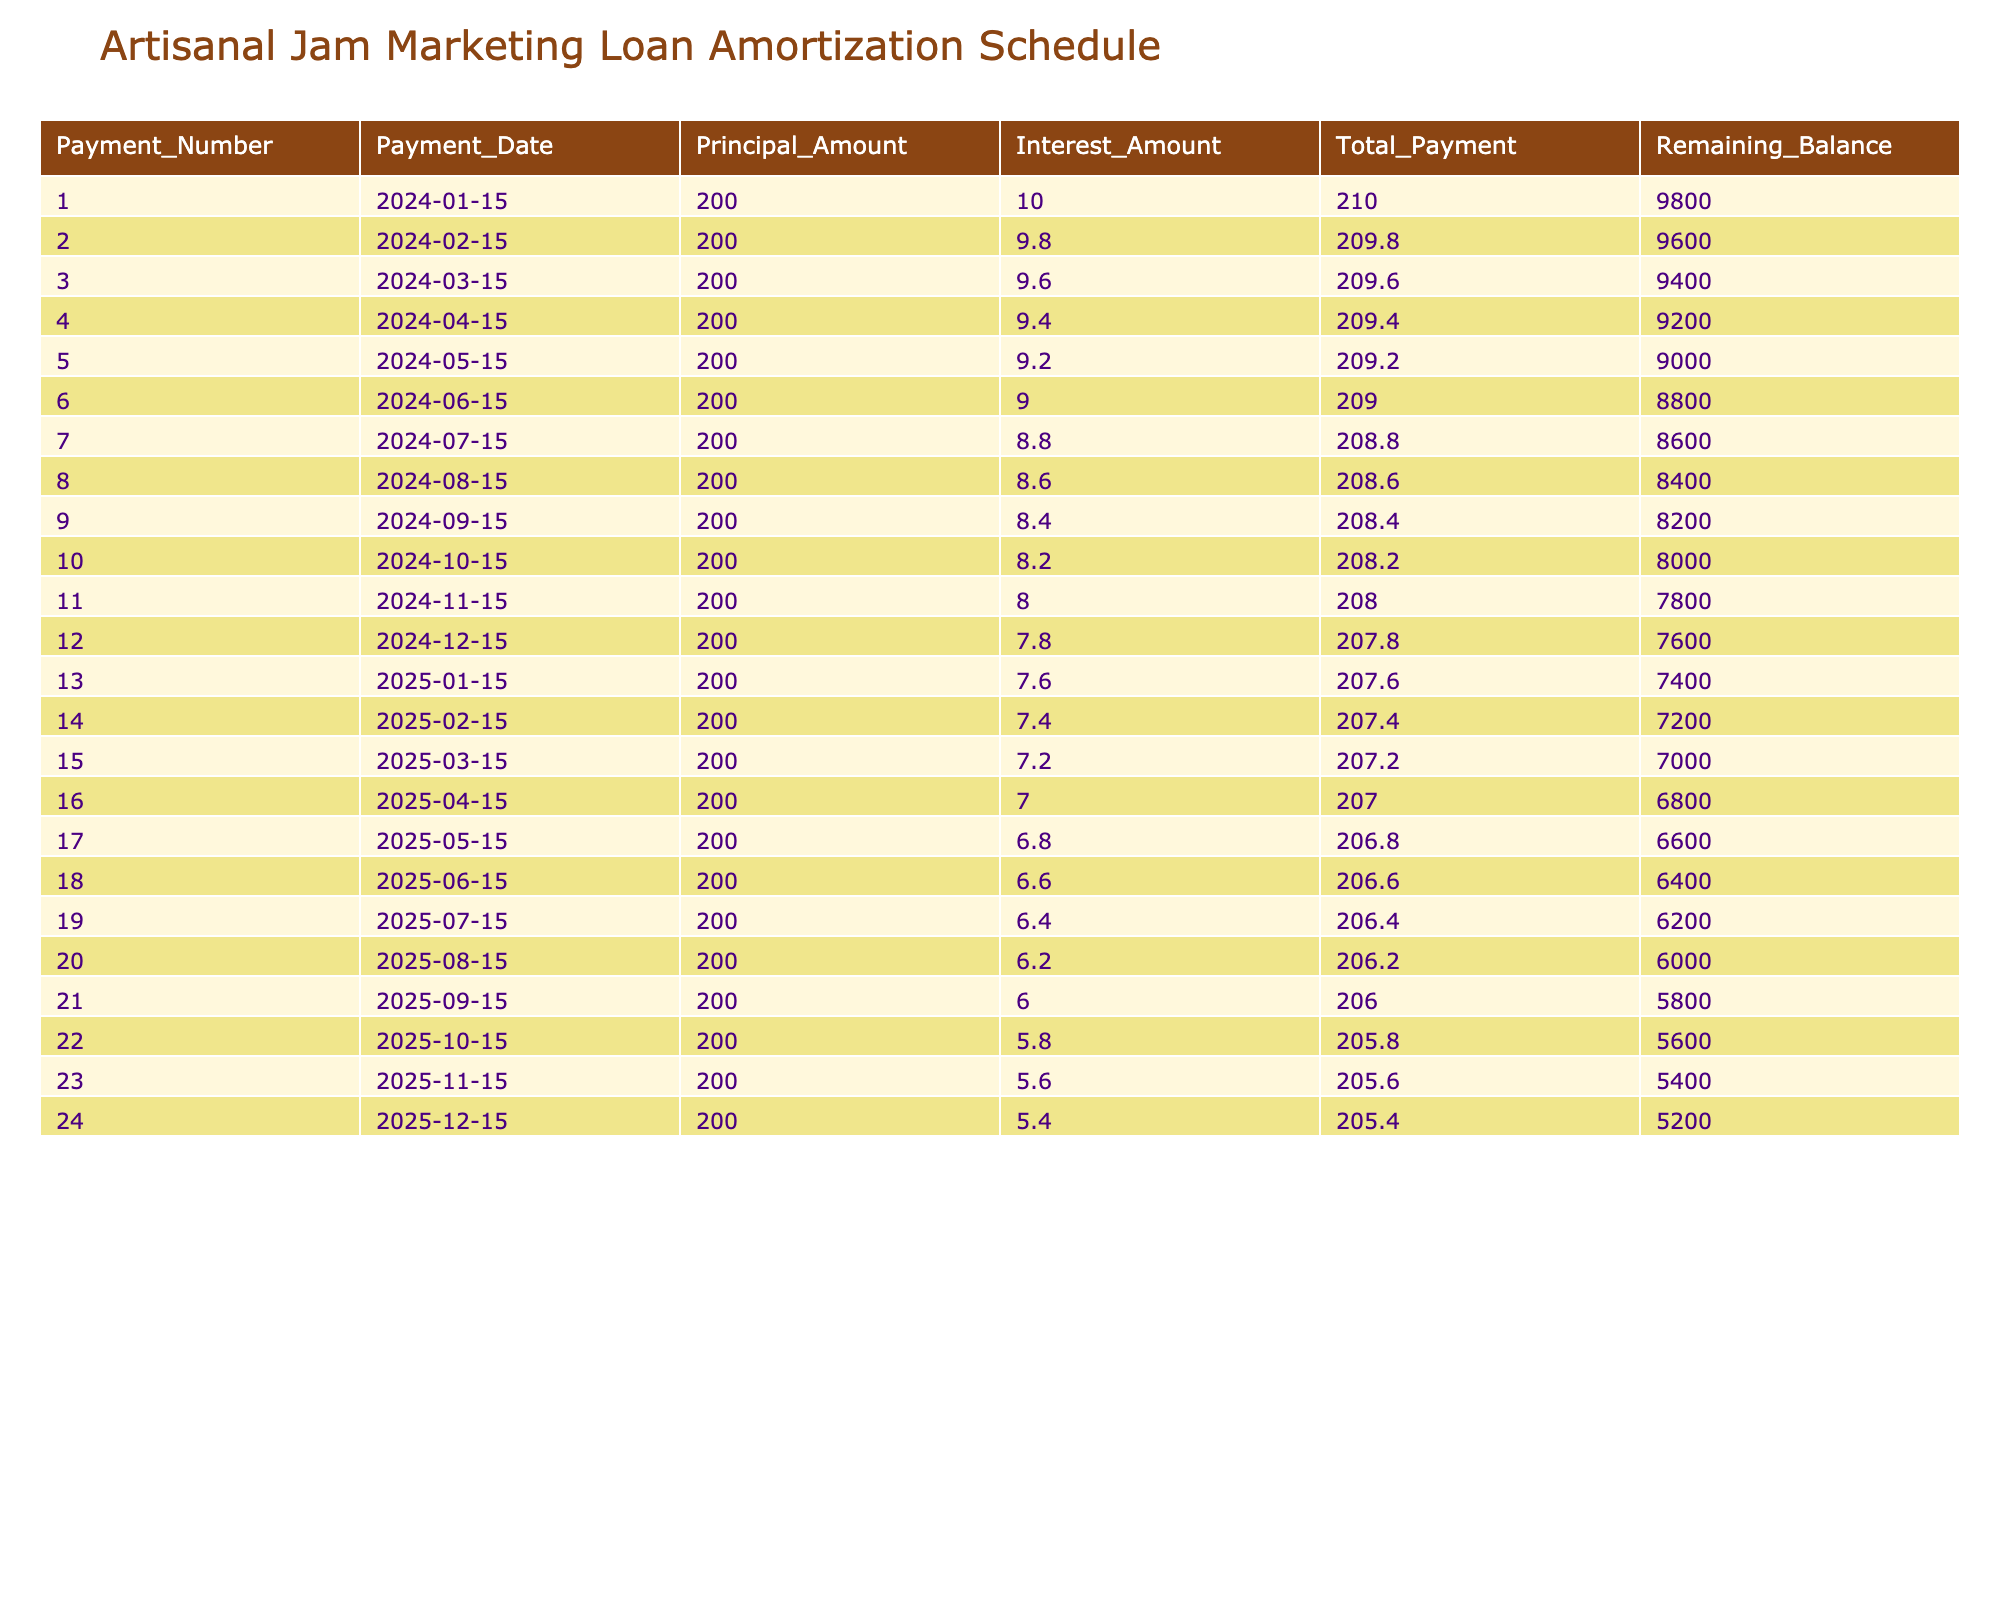What was the total payment for the first month? The first month (Payment Number 1) shows a total payment of 210.
Answer: 210 How much of the total payment in month 5 goes towards the principal? In month 5 (Payment Number 5), the principal amount is listed as 200.
Answer: 200 What is the remaining balance after the last payment? The last payment shows a remaining balance of 5200.
Answer: 5200 Did the interest amount decrease over time? Yes, the interest amount decreases with each payment, starting from 10 in the first month down to 5.40 in the last month.
Answer: Yes What is the average interest payment across the first three months? The interest payments for the first three months are 10, 9.80, and 9.60. Summing these gives 29.40, and dividing by 3 gives an average of 9.80.
Answer: 9.80 What is the total amount paid in interest after 12 months? To find the total interest paid in the first 12 months, we add the interest amounts for those months: (10 + 9.80 + 9.60 + 9.40 + 9.20 + 9 + 8.80 + 8.60 + 8.40 + 8.20 + 8 + 7.80) = 109.80.
Answer: 109.80 How much will be paid in principal over the first 10 months? The principal payment is consistent at 200 each month across the first 10 months. Therefore, the total will be 200 * 10 = 2000.
Answer: 2000 By how much does the remaining balance decrease each month? Every month, the remaining balance decreases by the principal amount, which is consistently 200 each month.
Answer: 200 